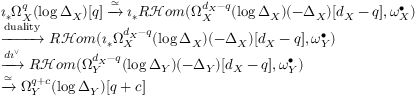<formula> <loc_0><loc_0><loc_500><loc_500>\begin{array} { r l } & { \imath _ { * } \Omega _ { X } ^ { q } ( \log \Delta _ { X } ) [ q ] \xrightarrow { \simeq } \imath _ { * } R \mathcal { H } o m ( \Omega _ { X } ^ { d _ { X } - q } ( \log \Delta _ { X } ) ( - \Delta _ { X } ) [ d _ { X } - q ] , \omega _ { X } ^ { \bullet } ) } \\ & { \xrightarrow { d u a l i t y } R \mathcal { H } o m ( \imath _ { * } \Omega _ { X } ^ { d _ { X } - q } ( \log \Delta _ { X } ) ( - \Delta _ { X } ) [ d _ { X } - q ] , \omega _ { Y } ^ { \bullet } ) } \\ & { \xrightarrow { d \imath ^ { \vee } } R \mathcal { H } o m ( \Omega _ { Y } ^ { d _ { X } - q } ( \log \Delta _ { Y } ) ( - \Delta _ { Y } ) [ d _ { X } - q ] , \omega _ { Y } ^ { \bullet } ) } \\ & { \xrightarrow { \simeq } \Omega _ { Y } ^ { q + c } ( \log \Delta _ { Y } ) [ q + c ] } \end{array}</formula> 